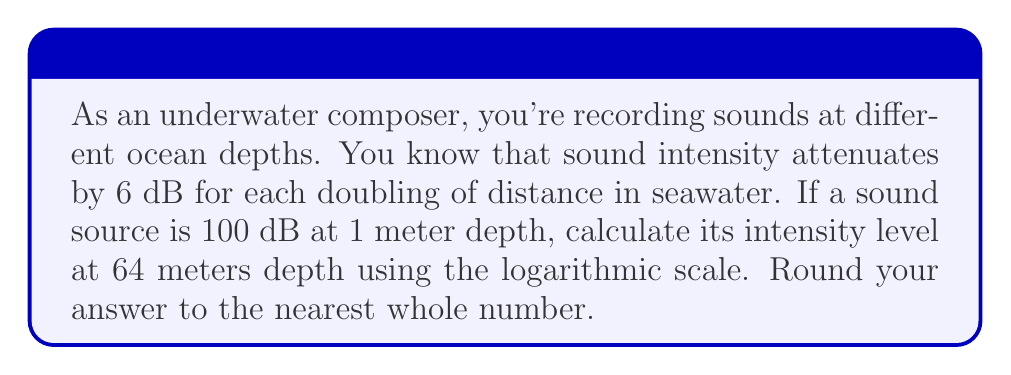Can you answer this question? Let's approach this step-by-step:

1) We know that sound intensity attenuates by 6 dB for each doubling of distance.

2) We need to determine how many times the distance has doubled from 1 meter to 64 meters:
   $2^6 = 64$, so the distance has doubled 6 times.

3) Each doubling results in a 6 dB reduction, so we multiply:
   $6 \text{ dB} \times 6 = 36 \text{ dB}$

4) The initial sound intensity is 100 dB at 1 meter.

5) To find the intensity at 64 meters, we subtract the total attenuation:
   $100 \text{ dB} - 36 \text{ dB} = 64 \text{ dB}$

6) The formula for this calculation can be expressed as:
   $$I = I_0 - 20 \log_{10}(d/d_0)$$
   Where $I$ is the intensity at distance $d$, $I_0$ is the initial intensity at distance $d_0$, and $d/d_0$ is the ratio of distances.

7) Plugging in our values:
   $$I = 100 - 20 \log_{10}(64/1) = 100 - 20 \log_{10}(64) = 100 - 36 = 64 \text{ dB}$$

8) Rounding to the nearest whole number: 64 dB
Answer: 64 dB 